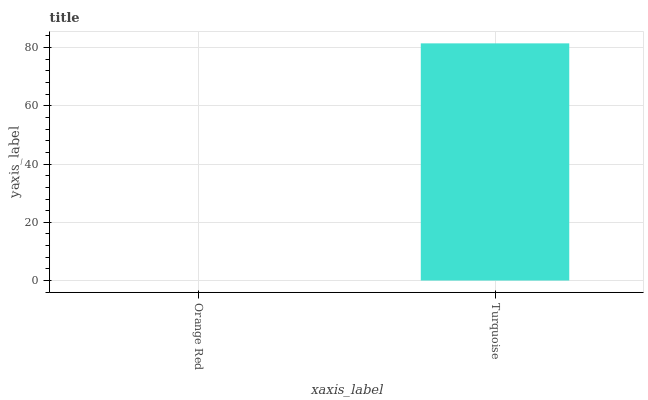Is Orange Red the minimum?
Answer yes or no. Yes. Is Turquoise the maximum?
Answer yes or no. Yes. Is Turquoise the minimum?
Answer yes or no. No. Is Turquoise greater than Orange Red?
Answer yes or no. Yes. Is Orange Red less than Turquoise?
Answer yes or no. Yes. Is Orange Red greater than Turquoise?
Answer yes or no. No. Is Turquoise less than Orange Red?
Answer yes or no. No. Is Turquoise the high median?
Answer yes or no. Yes. Is Orange Red the low median?
Answer yes or no. Yes. Is Orange Red the high median?
Answer yes or no. No. Is Turquoise the low median?
Answer yes or no. No. 